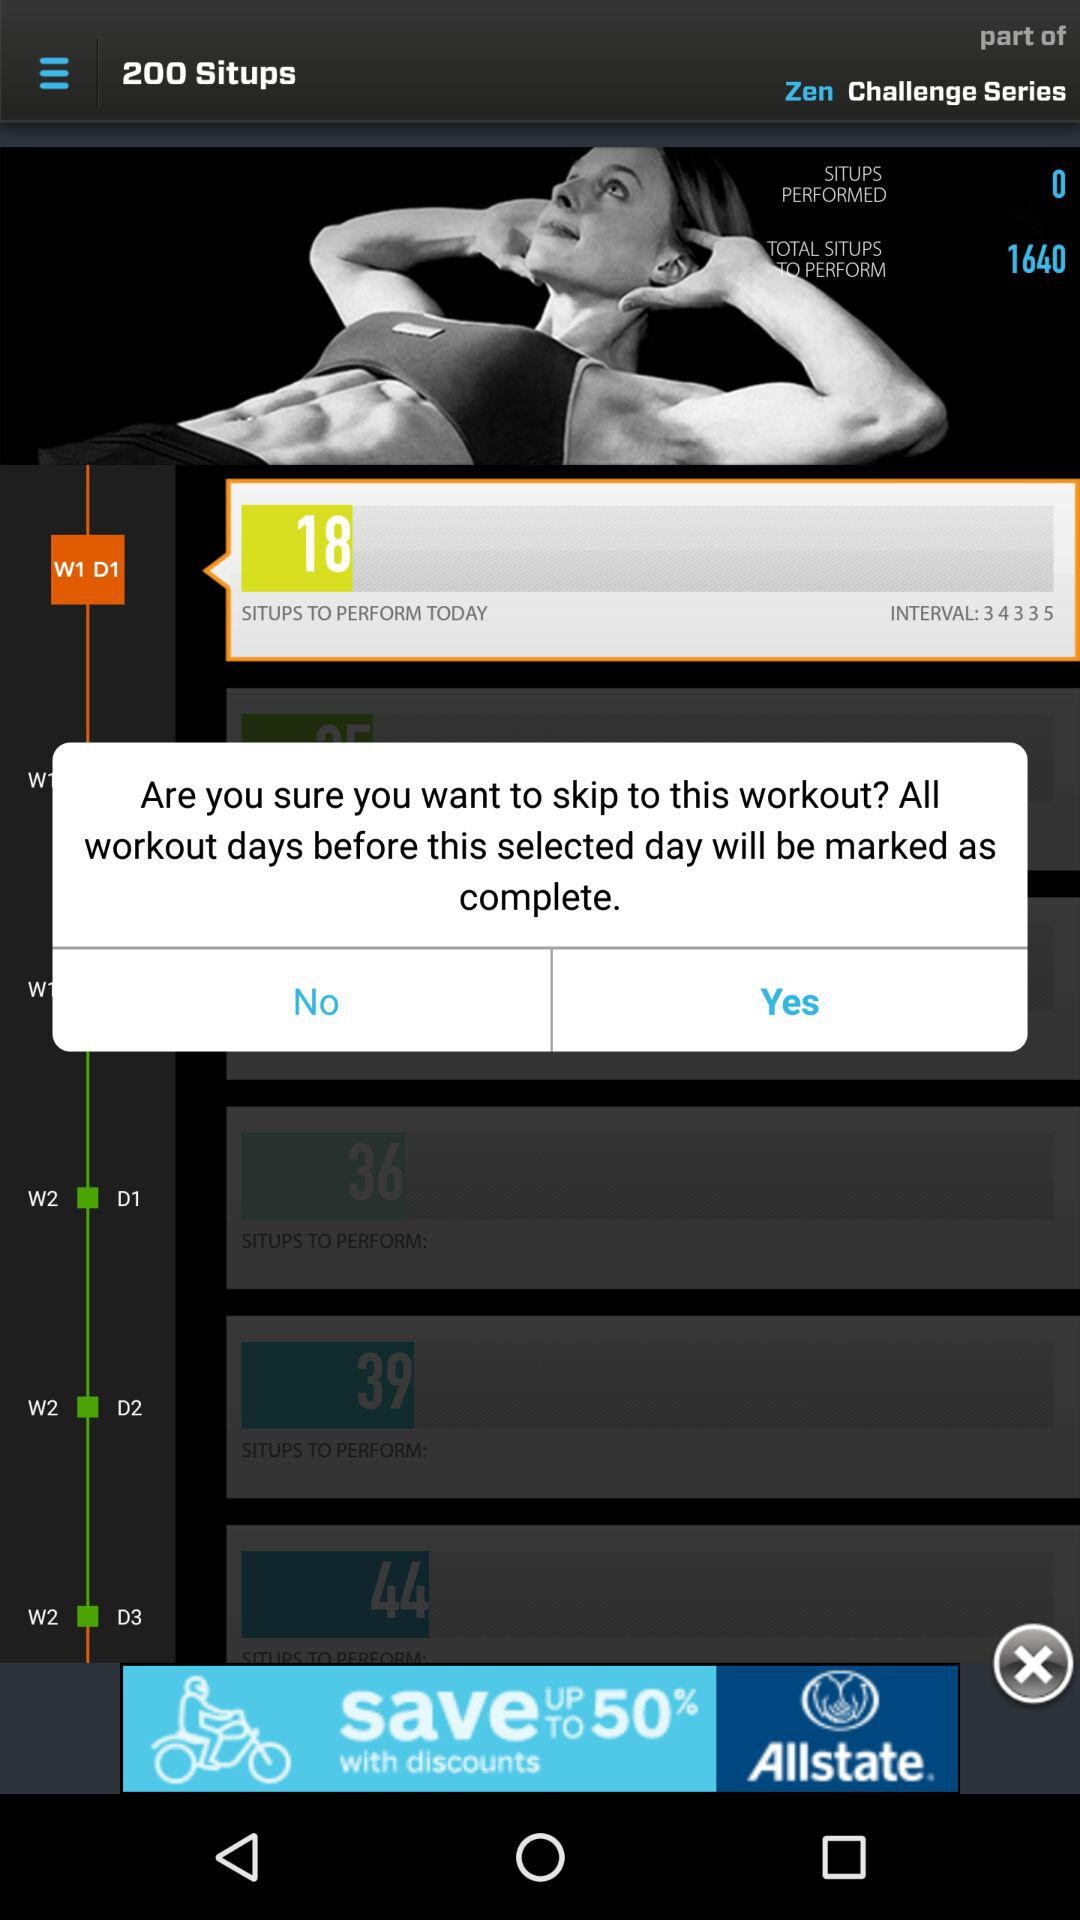What is the total number of situps performed? The total number of situps performed is 0. 